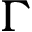Convert formula to latex. <formula><loc_0><loc_0><loc_500><loc_500>\Gamma</formula> 